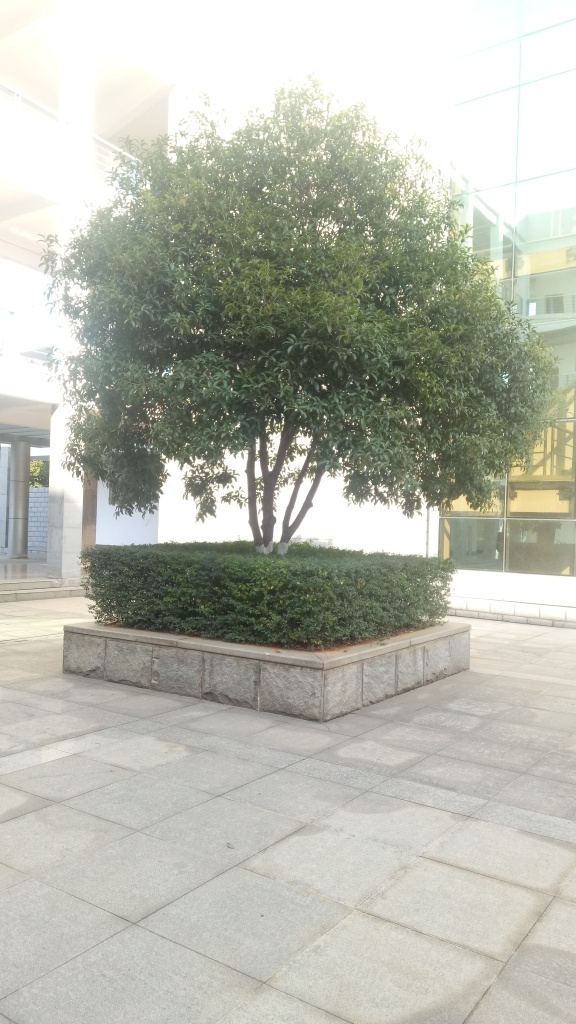Could this place be suitable for leisure activities? Certainly, the spacious surroundings and well-manicured greenery suggest that this could be a pleasant spot for relaxation, perhaps for activities like reading a book or enjoying a quiet lunch outdoors. 